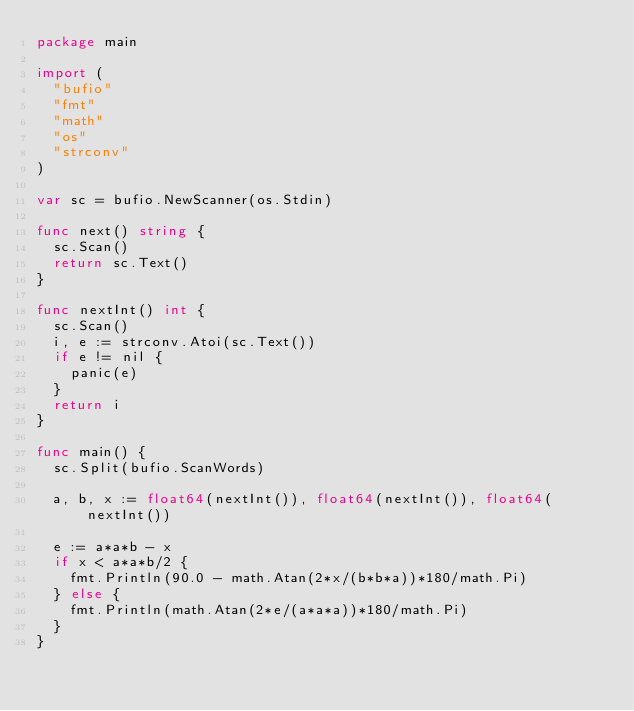<code> <loc_0><loc_0><loc_500><loc_500><_Go_>package main

import (
	"bufio"
	"fmt"
	"math"
	"os"
	"strconv"
)

var sc = bufio.NewScanner(os.Stdin)

func next() string {
	sc.Scan()
	return sc.Text()
}

func nextInt() int {
	sc.Scan()
	i, e := strconv.Atoi(sc.Text())
	if e != nil {
		panic(e)
	}
	return i
}

func main() {
	sc.Split(bufio.ScanWords)

	a, b, x := float64(nextInt()), float64(nextInt()), float64(nextInt())

	e := a*a*b - x
	if x < a*a*b/2 {
		fmt.Println(90.0 - math.Atan(2*x/(b*b*a))*180/math.Pi)
	} else {
		fmt.Println(math.Atan(2*e/(a*a*a))*180/math.Pi)
	}
}</code> 